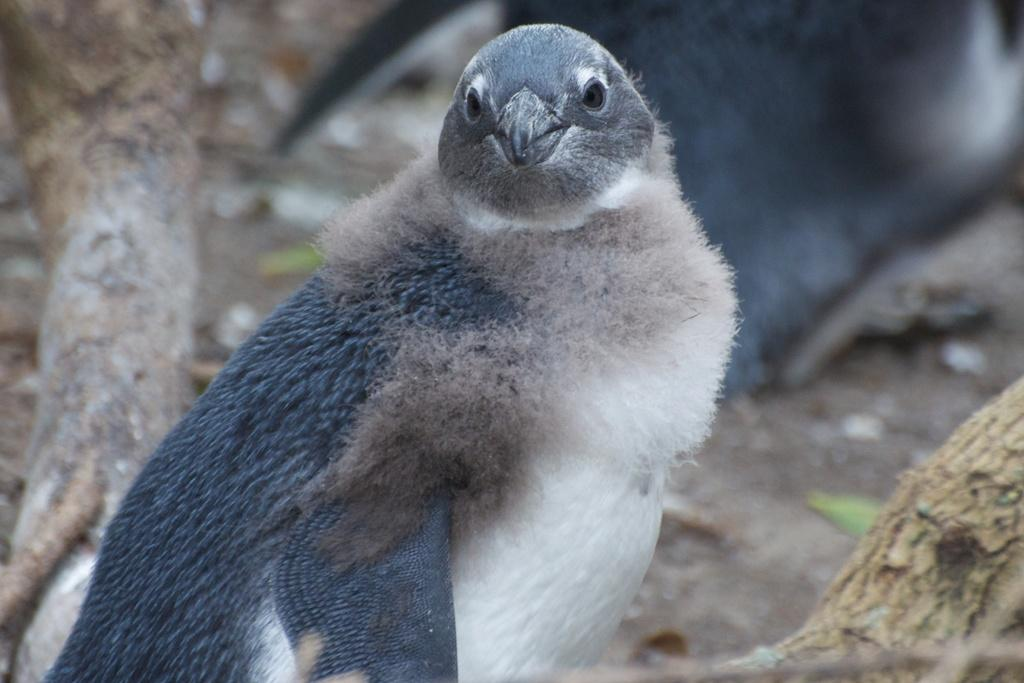Where was the image taken? The image was taken outdoors. What can be seen in the background of the image? There is a tree in the background of the image. What is present in the middle of the image? There is a bird on a branch in the middle of the image. How many beetles can be seen crawling on the bird's beak in the image? There are no beetles present in the image, and the bird's beak is not visible. 